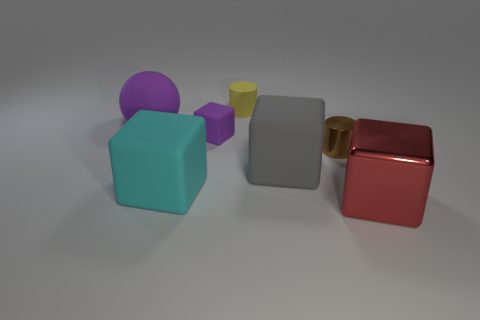What number of rubber cylinders are the same color as the tiny rubber block?
Make the answer very short. 0. There is a cylinder behind the large purple thing; is it the same color as the thing to the left of the large cyan block?
Keep it short and to the point. No. There is a small rubber cylinder; are there any large red metal cubes on the left side of it?
Provide a short and direct response. No. What is the material of the big purple object?
Give a very brief answer. Rubber. There is a shiny thing to the left of the large metallic block; what shape is it?
Offer a terse response. Cylinder. What size is the object that is the same color as the tiny cube?
Ensure brevity in your answer.  Large. Are there any balls that have the same size as the shiny cylinder?
Your response must be concise. No. Do the tiny thing on the right side of the yellow cylinder and the large red object have the same material?
Provide a succinct answer. Yes. Are there an equal number of purple rubber things left of the rubber ball and matte cylinders that are in front of the big red metal cube?
Provide a succinct answer. Yes. What shape is the matte thing that is both in front of the tiny purple rubber thing and on the right side of the big cyan thing?
Give a very brief answer. Cube. 